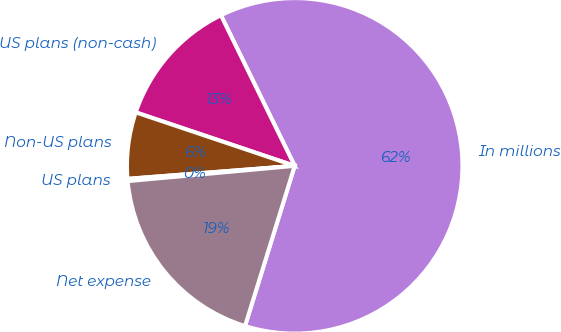Convert chart to OTSL. <chart><loc_0><loc_0><loc_500><loc_500><pie_chart><fcel>In millions<fcel>US plans (non-cash)<fcel>Non-US plans<fcel>US plans<fcel>Net expense<nl><fcel>62.04%<fcel>12.58%<fcel>6.4%<fcel>0.22%<fcel>18.76%<nl></chart> 